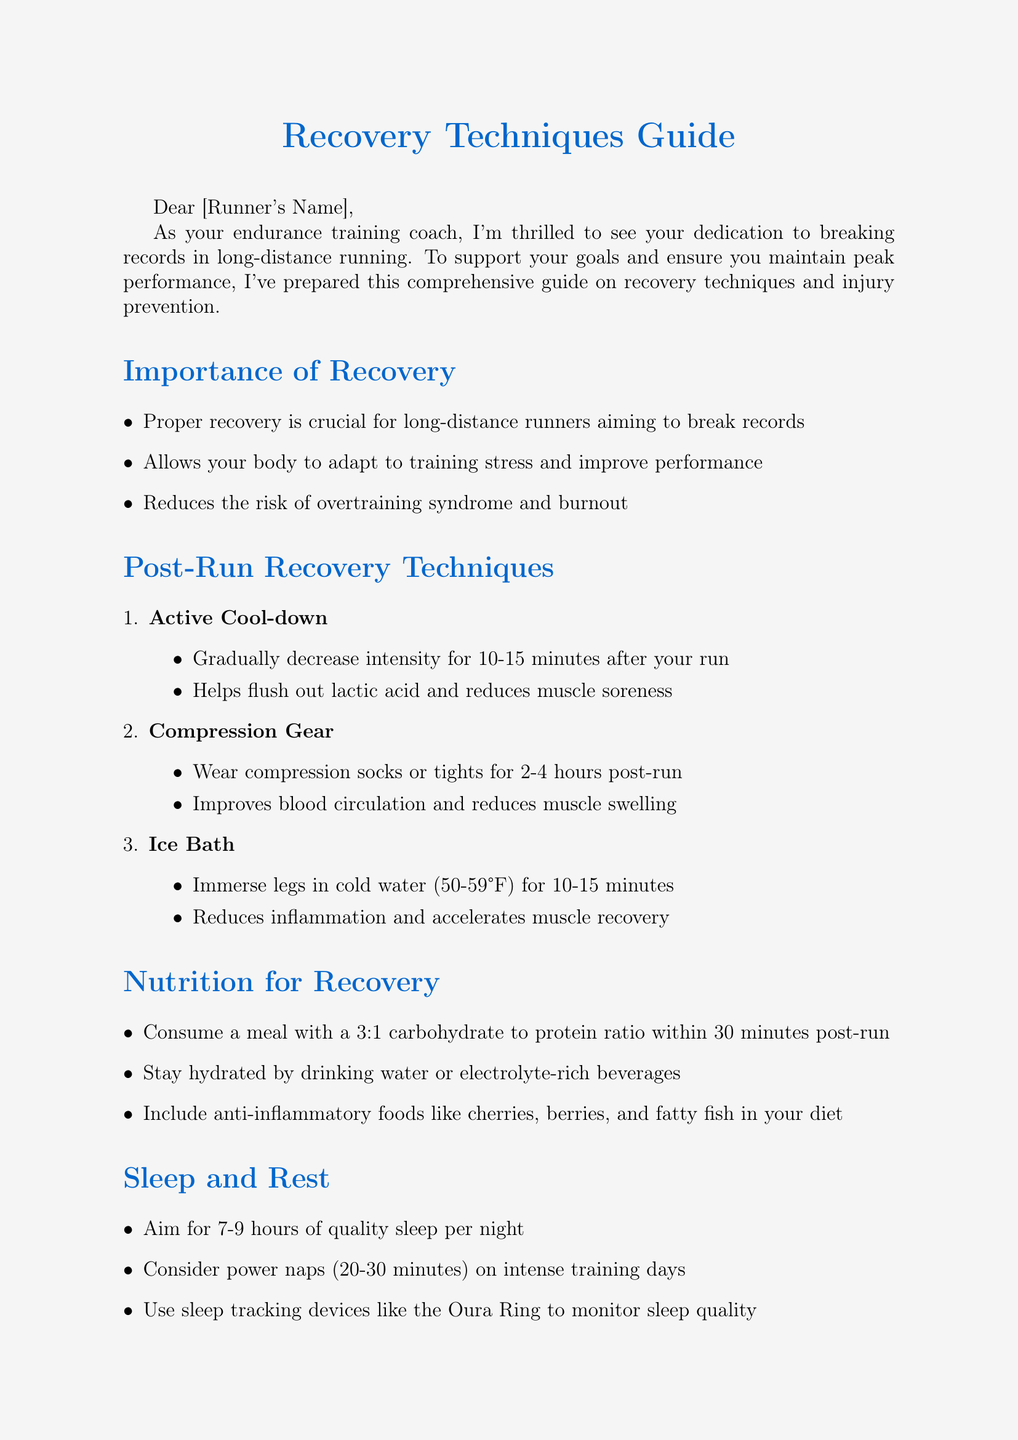What is the title of the document? The title of the document is explicitly mentioned at the beginning, which is "Recovery Techniques Guide."
Answer: Recovery Techniques Guide How many post-run recovery techniques are listed? The document mentions three specific post-run recovery techniques in the relevant section.
Answer: 3 What is the recommended carbohydrate to protein ratio for post-run meals? The document specifies a 3:1 carbohydrate to protein ratio to be consumed within 30 minutes post-run.
Answer: 3:1 What is one recommended sleep duration for recovery? The document suggests aiming for between 7-9 hours of quality sleep per night for recovery.
Answer: 7-9 hours Which device is mentioned for monitoring sleep quality? The document includes the Oura Ring as a device to monitor sleep quality.
Answer: Oura Ring What type of footwear is advised to reduce injury risk? The document recommends rotating between 2-3 pairs of running shoes for injury prevention.
Answer: 2-3 pairs What is one benefit of active cool-down? The document states that active cool-down helps flush out lactic acid and reduces muscle soreness.
Answer: Reduces muscle soreness What should be included in a recovery meal? The document suggests including a meal with a carbohydrate to protein ratio for recovery.
Answer: Meal with 3:1 ratio What is the purpose of foam rolling in injury prevention? The benefit of foam rolling mentioned in the document is that it releases muscle tension and improves flexibility.
Answer: Releases muscle tension 